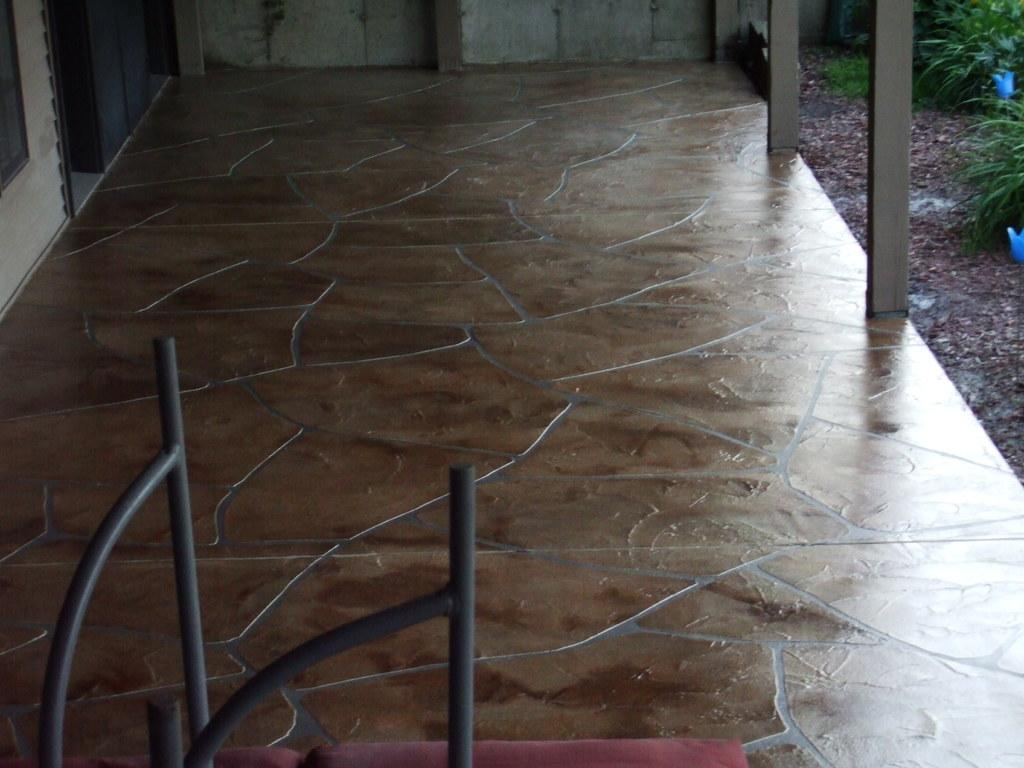What is located on the floor in the image? There is an object on the floor in the image. What type of objects can be seen in the image besides the object on the floor? There are wooden poles and plants on the ground visible in the image. What can be seen in the background of the image? There is a wall visible in the background of the image. What is the temperature of the fork in the image? There is no fork present in the image, so it is not possible to determine its temperature. 